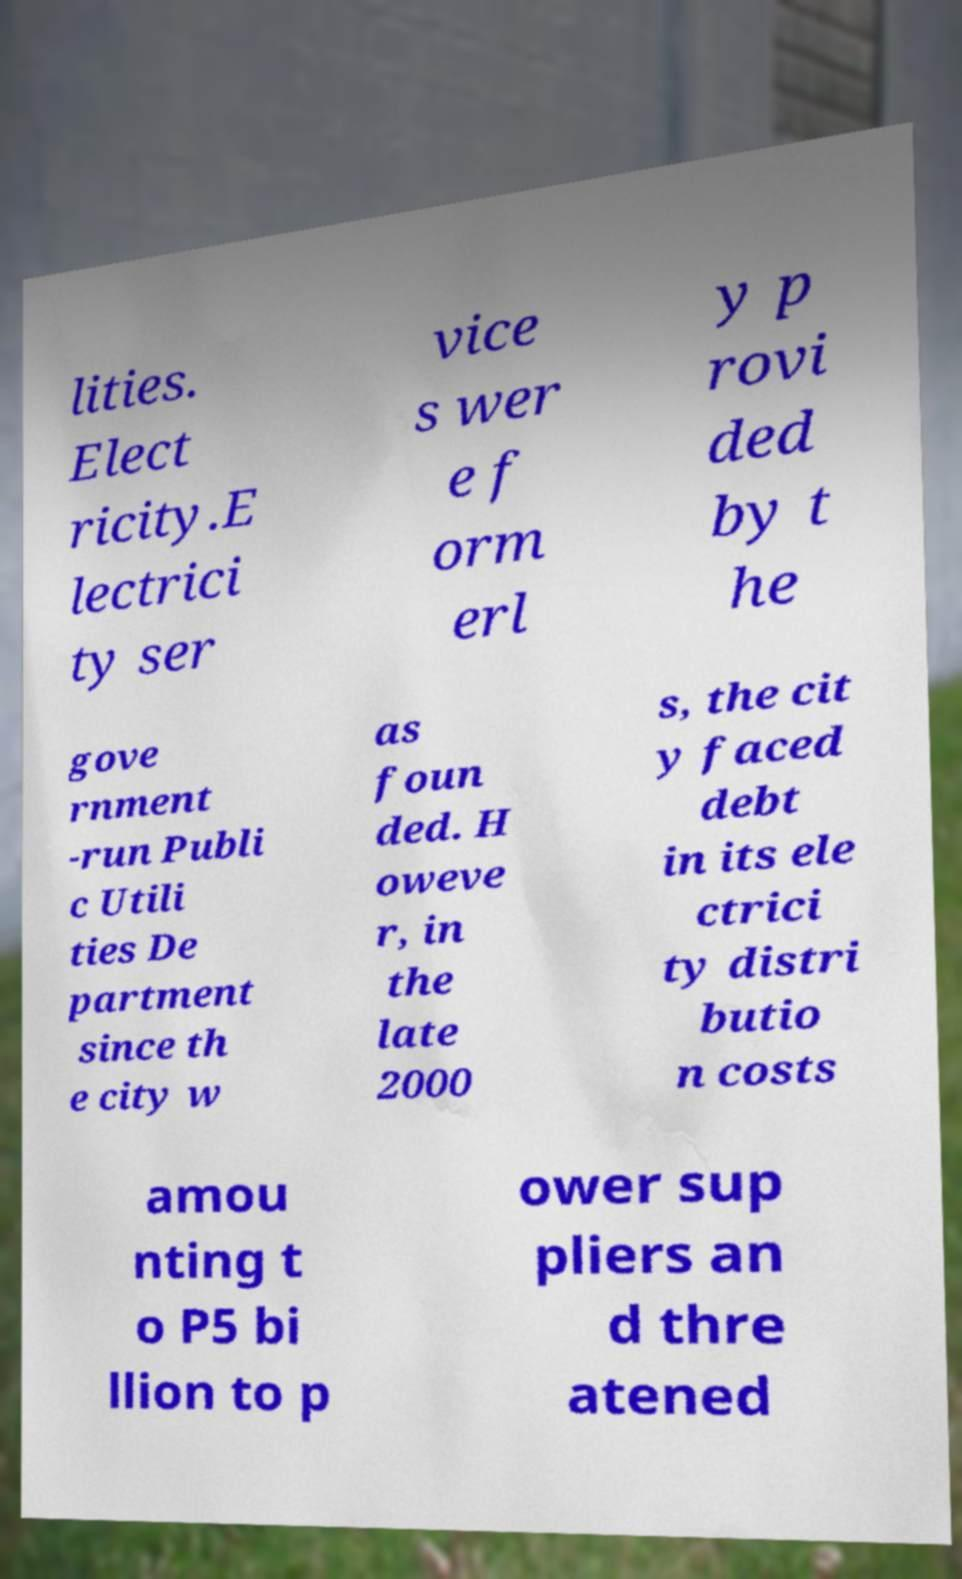Could you extract and type out the text from this image? lities. Elect ricity.E lectrici ty ser vice s wer e f orm erl y p rovi ded by t he gove rnment -run Publi c Utili ties De partment since th e city w as foun ded. H oweve r, in the late 2000 s, the cit y faced debt in its ele ctrici ty distri butio n costs amou nting t o P5 bi llion to p ower sup pliers an d thre atened 